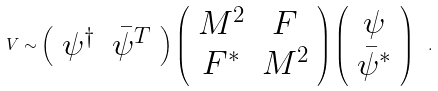Convert formula to latex. <formula><loc_0><loc_0><loc_500><loc_500>V \sim \left ( \begin{array} { c c } \psi ^ { \dagger } & \bar { \psi } ^ { T } \end{array} \right ) \left ( \begin{array} { c c } M ^ { 2 } & F \\ F ^ { * } & M ^ { 2 } \end{array} \right ) \left ( \begin{array} { c } \psi \\ \bar { \psi } ^ { * } \end{array} \right ) \ .</formula> 